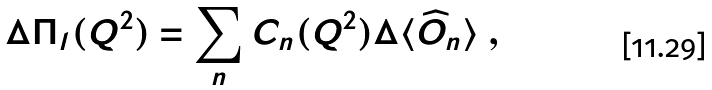<formula> <loc_0><loc_0><loc_500><loc_500>\Delta \Pi _ { l } ( Q ^ { 2 } ) = \sum _ { n } C _ { n } ( Q ^ { 2 } ) \Delta \langle \widehat { O } _ { n } \rangle \ ,</formula> 